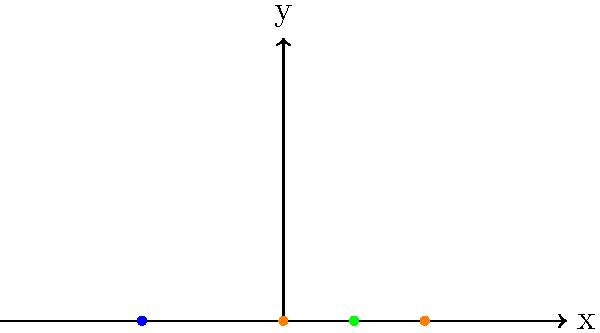In a traditional dance from your country, a dancer moves through four positions (A, B, C, and D) as shown in the diagram. Assuming the dancer's body can be modeled as a point mass, calculate the total displacement of the center of mass from the initial position A to the final position D. Express your answer in terms of the unit length used in the diagram. To calculate the total displacement of the center of mass, we need to follow these steps:

1. Identify the coordinates of the initial (A) and final (D) positions:
   A: (0, 0)
   D: (0, 1)

2. Calculate the displacement vector:
   Displacement = Final position - Initial position
   $$\vec{d} = (0, 1) - (0, 0) = (0, 1)$$

3. Calculate the magnitude of the displacement vector using the Pythagorean theorem:
   $$|\vec{d}| = \sqrt{(0)^2 + (1)^2} = \sqrt{1} = 1$$

The total displacement is 1 unit in the vertical direction.

Note: The intermediate positions (B and C) do not affect the total displacement, as displacement only depends on the initial and final positions.
Answer: 1 unit 